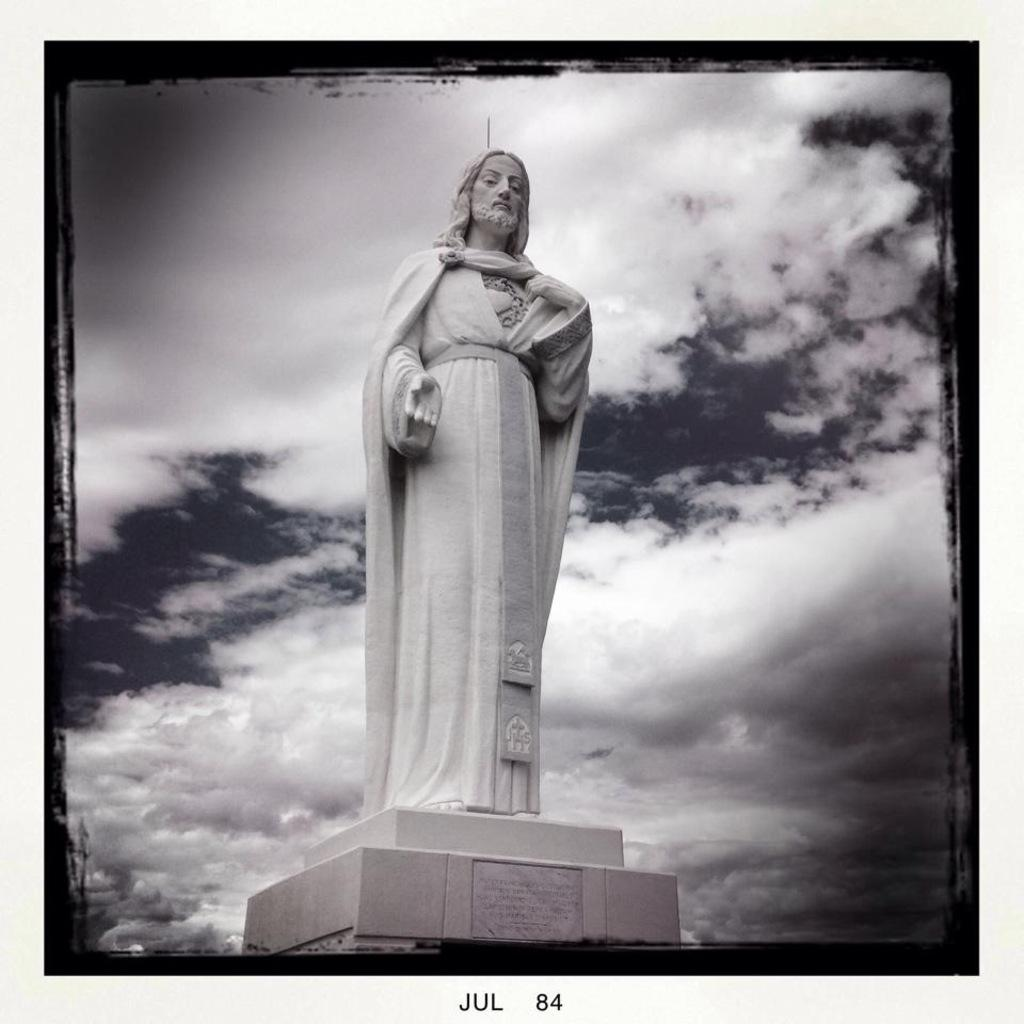What is the main subject in the middle of the image? There is a statue in the middle of the image. How would you describe the sky in the background? The sky in the background is cloudy. Is there any text present in the image? Yes, there is text at the bottom of the image. What type of drink is being served at the event in the image? There is no event or drink present in the image; it features a statue and cloudy sky in the background. What time of day is depicted in the image? The time of day cannot be determined from the image, as there are no specific clues. 